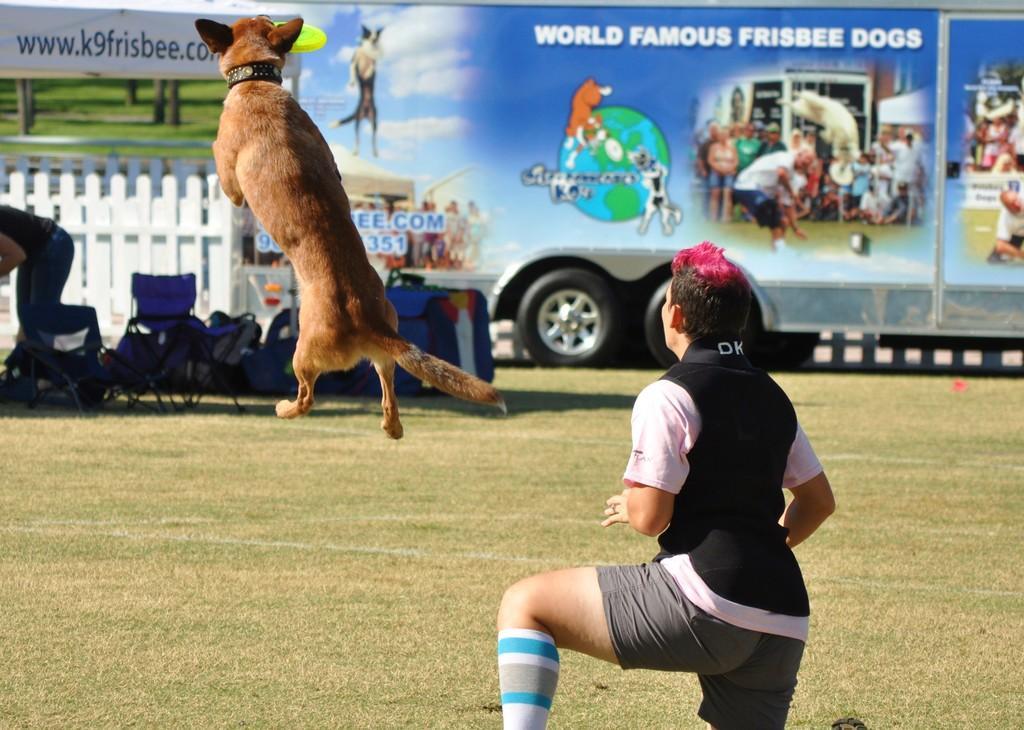Describe this image in one or two sentences. It is a ground a person is sitting on the ground, a dog is jumping in the air behind the dog there are some other chairs and luggage, in the background there is a vehicle. 